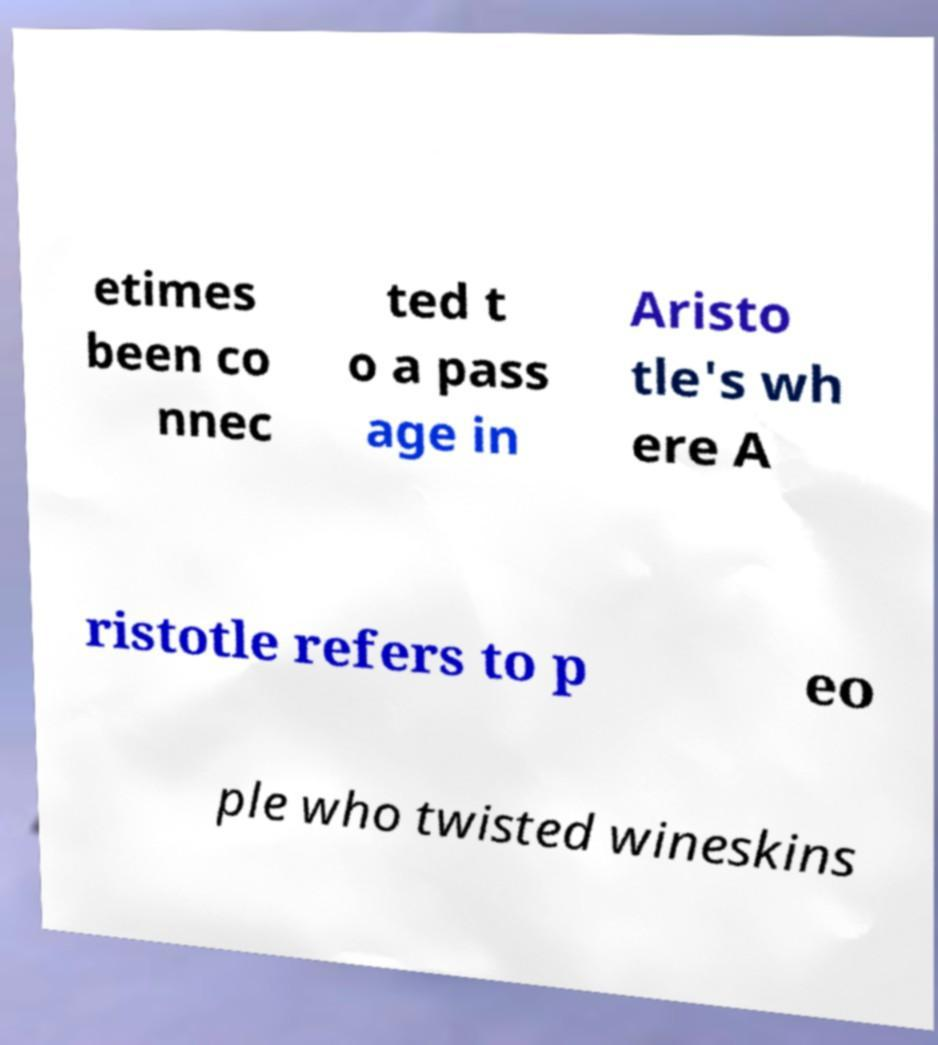I need the written content from this picture converted into text. Can you do that? etimes been co nnec ted t o a pass age in Aristo tle's wh ere A ristotle refers to p eo ple who twisted wineskins 